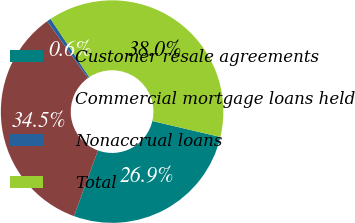Convert chart to OTSL. <chart><loc_0><loc_0><loc_500><loc_500><pie_chart><fcel>Customer resale agreements<fcel>Commercial mortgage loans held<fcel>Nonaccrual loans<fcel>Total<nl><fcel>26.9%<fcel>34.52%<fcel>0.6%<fcel>37.98%<nl></chart> 